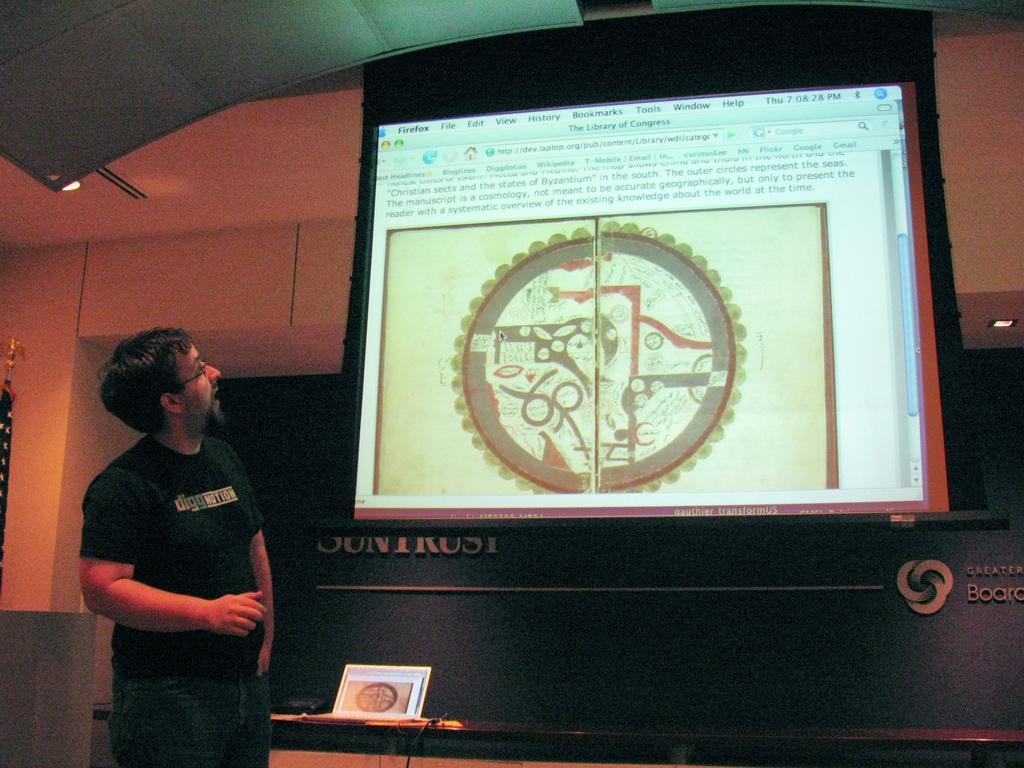Can you describe this image briefly? In the picture we can see a man standing near the wall with a screen and on it we can see some information with some image and he is looking at the screen and he is wearing a black T-shirt and beside him we can see a desk with a photo frame on it. 